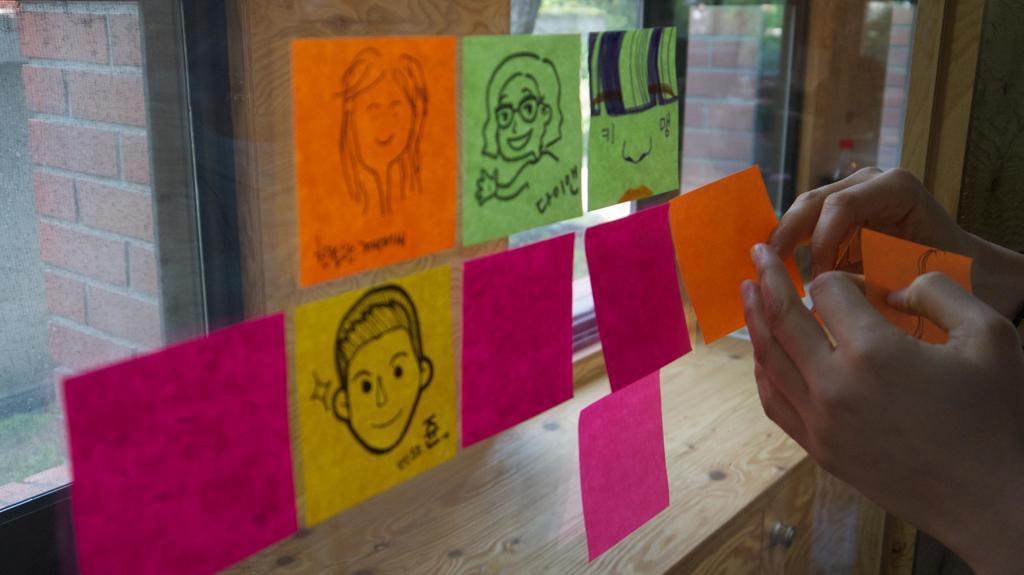Please provide a concise description of this image. In the center of the image there is a glass on which there are papers pasted. There is a person's hand at the right side of the image. 